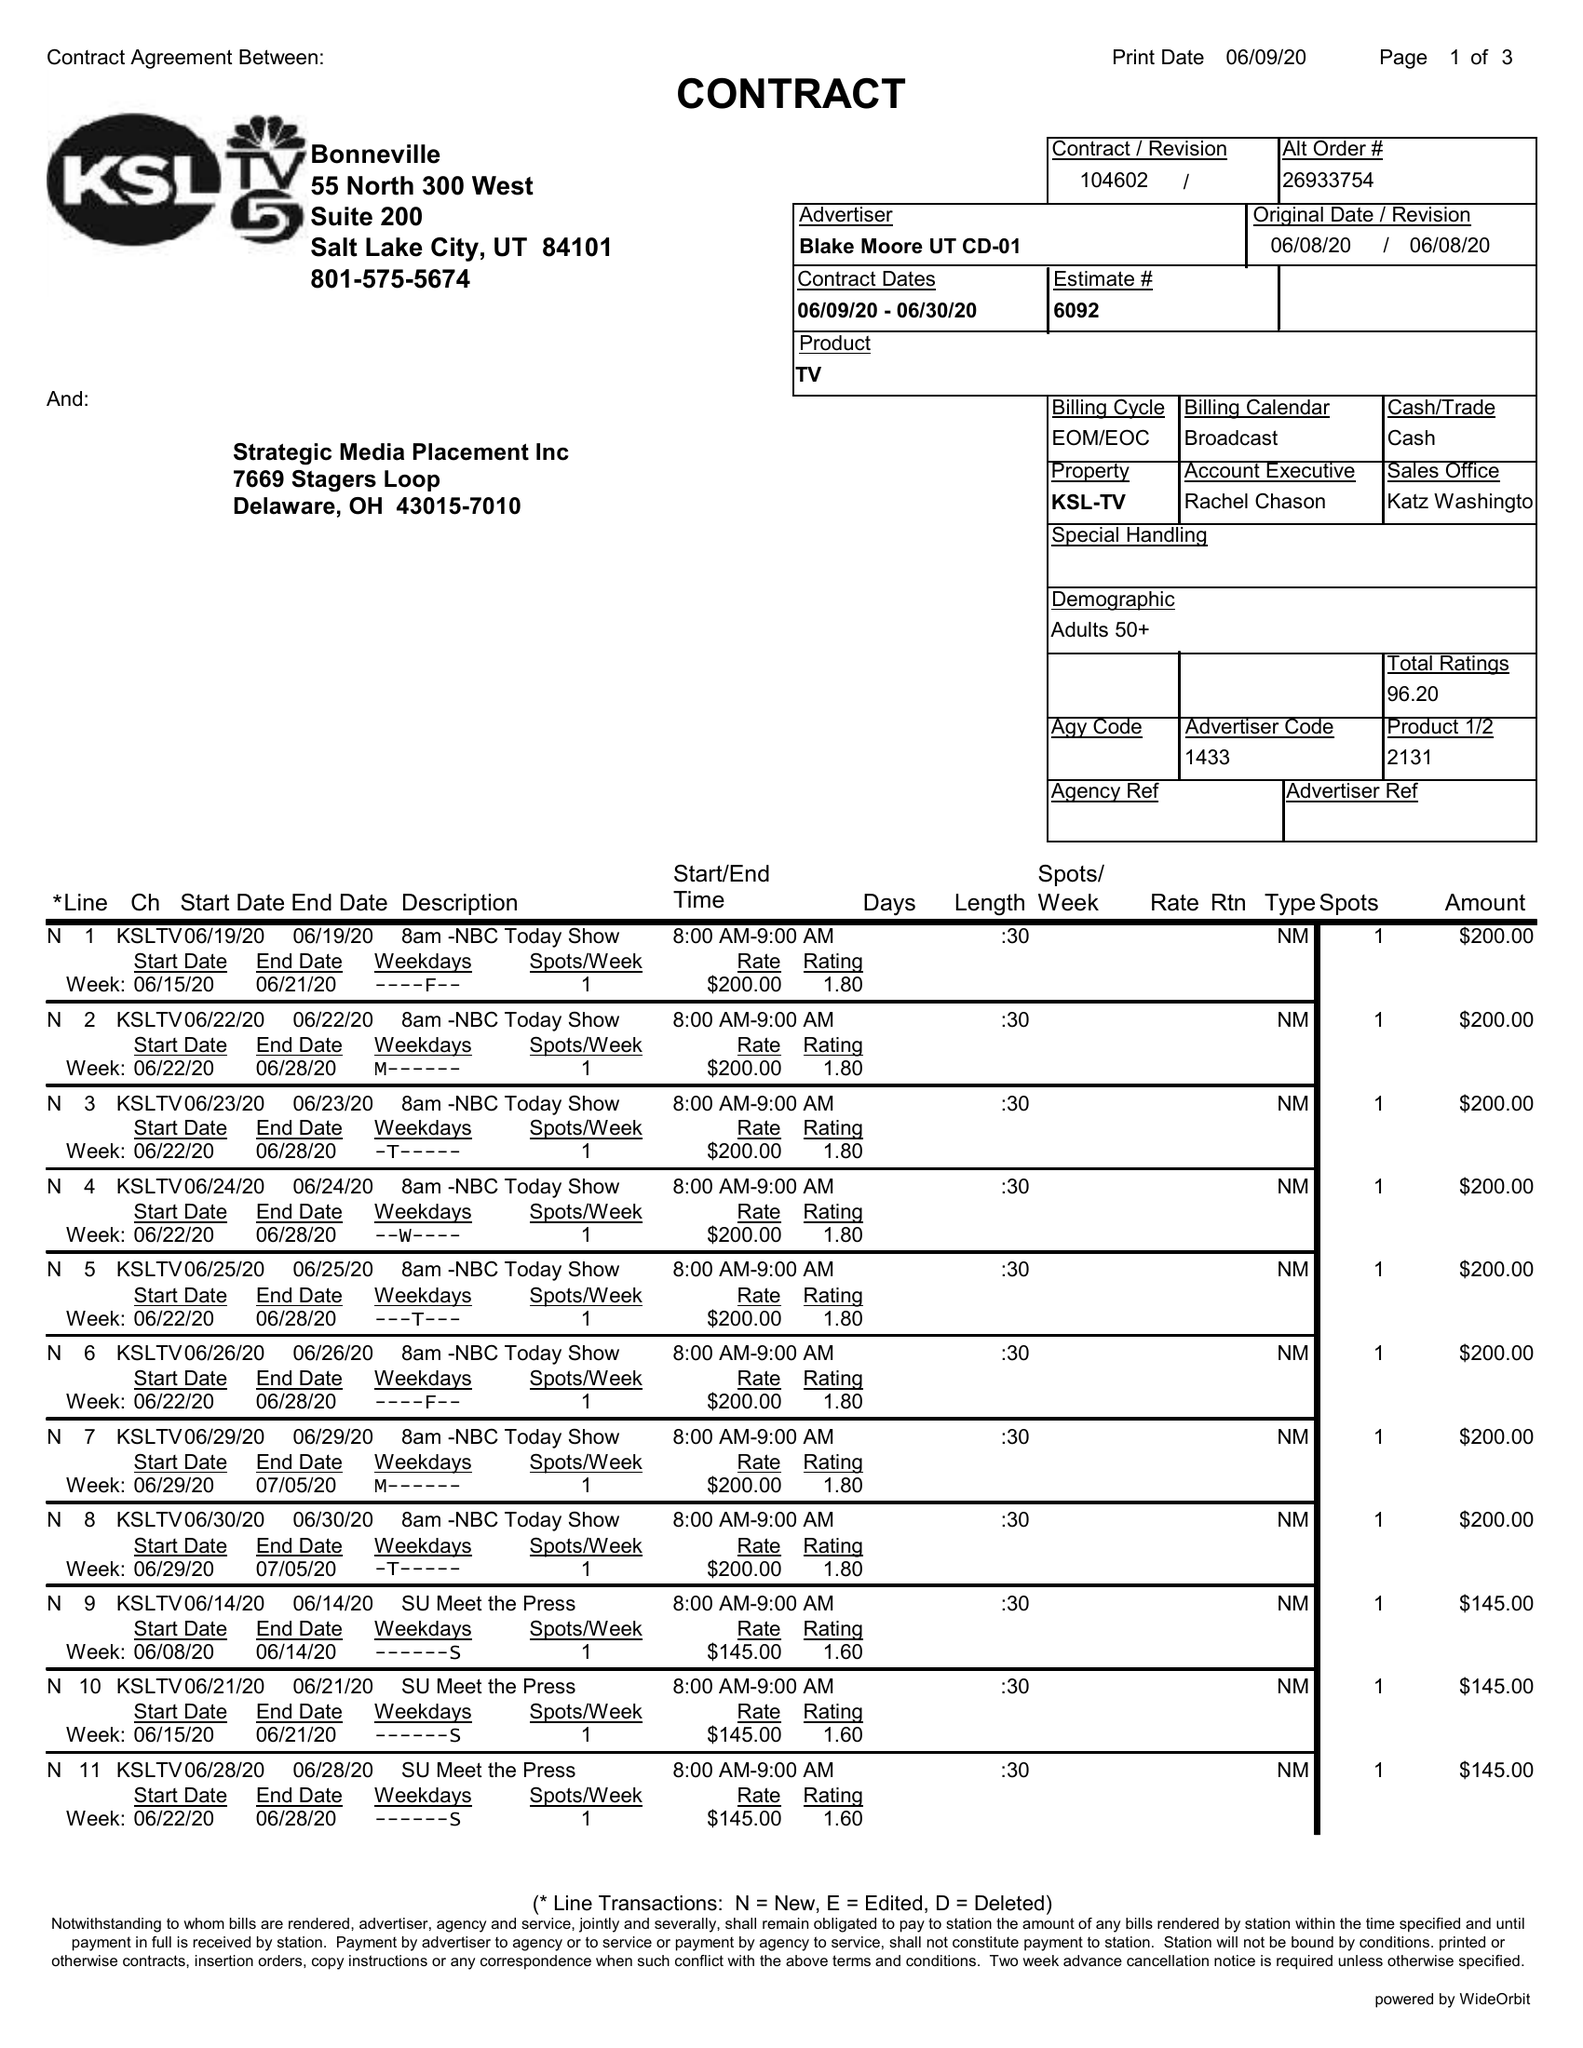What is the value for the advertiser?
Answer the question using a single word or phrase. BLAKE MOORE UT CD-01 